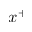Convert formula to latex. <formula><loc_0><loc_0><loc_500><loc_500>x ^ { + }</formula> 